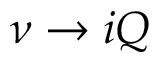<formula> <loc_0><loc_0><loc_500><loc_500>\nu \to i Q</formula> 